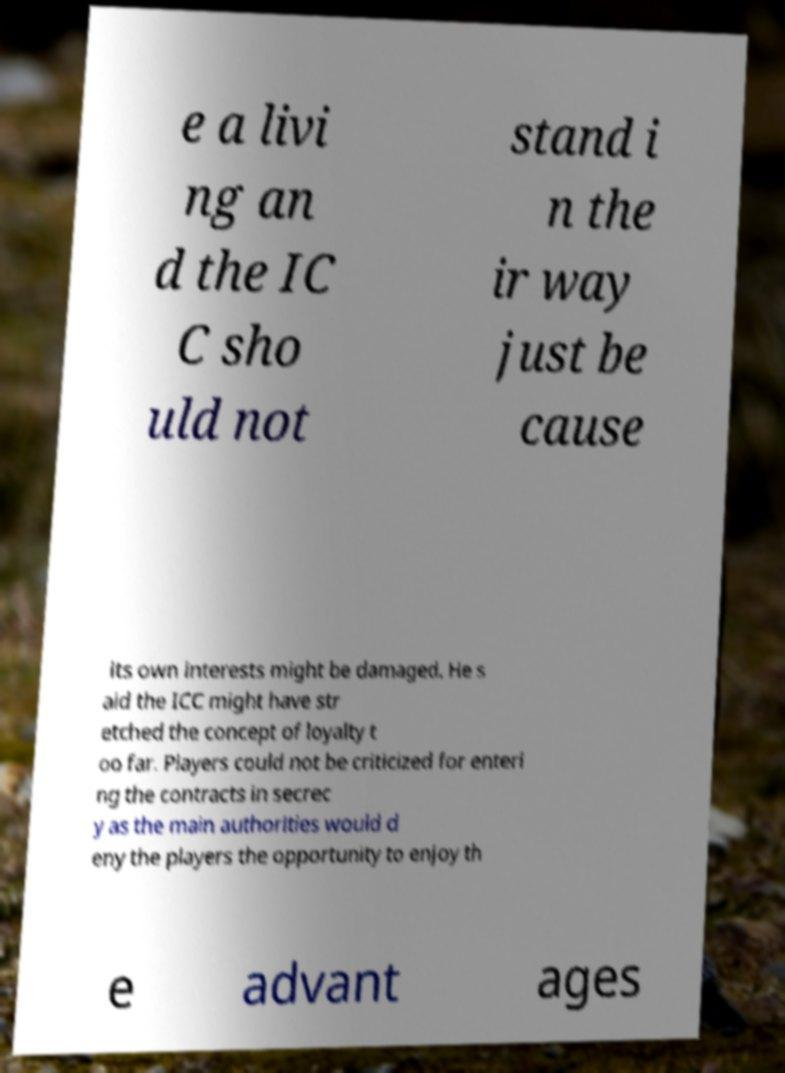For documentation purposes, I need the text within this image transcribed. Could you provide that? e a livi ng an d the IC C sho uld not stand i n the ir way just be cause its own interests might be damaged. He s aid the ICC might have str etched the concept of loyalty t oo far. Players could not be criticized for enteri ng the contracts in secrec y as the main authorities would d eny the players the opportunity to enjoy th e advant ages 